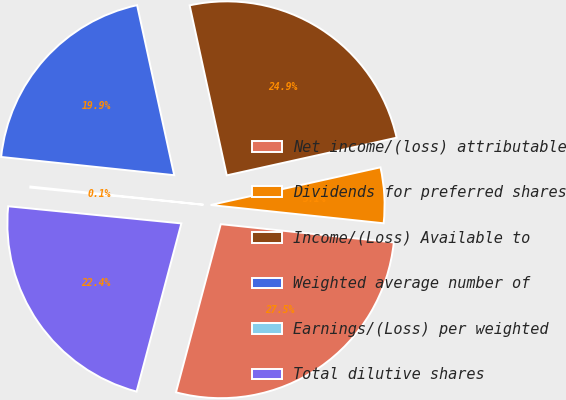Convert chart. <chart><loc_0><loc_0><loc_500><loc_500><pie_chart><fcel>Net income/(loss) attributable<fcel>Dividends for preferred shares<fcel>Income/(Loss) Available to<fcel>Weighted average number of<fcel>Earnings/(Loss) per weighted<fcel>Total dilutive shares<nl><fcel>27.47%<fcel>5.15%<fcel>24.95%<fcel>19.91%<fcel>0.1%<fcel>22.43%<nl></chart> 